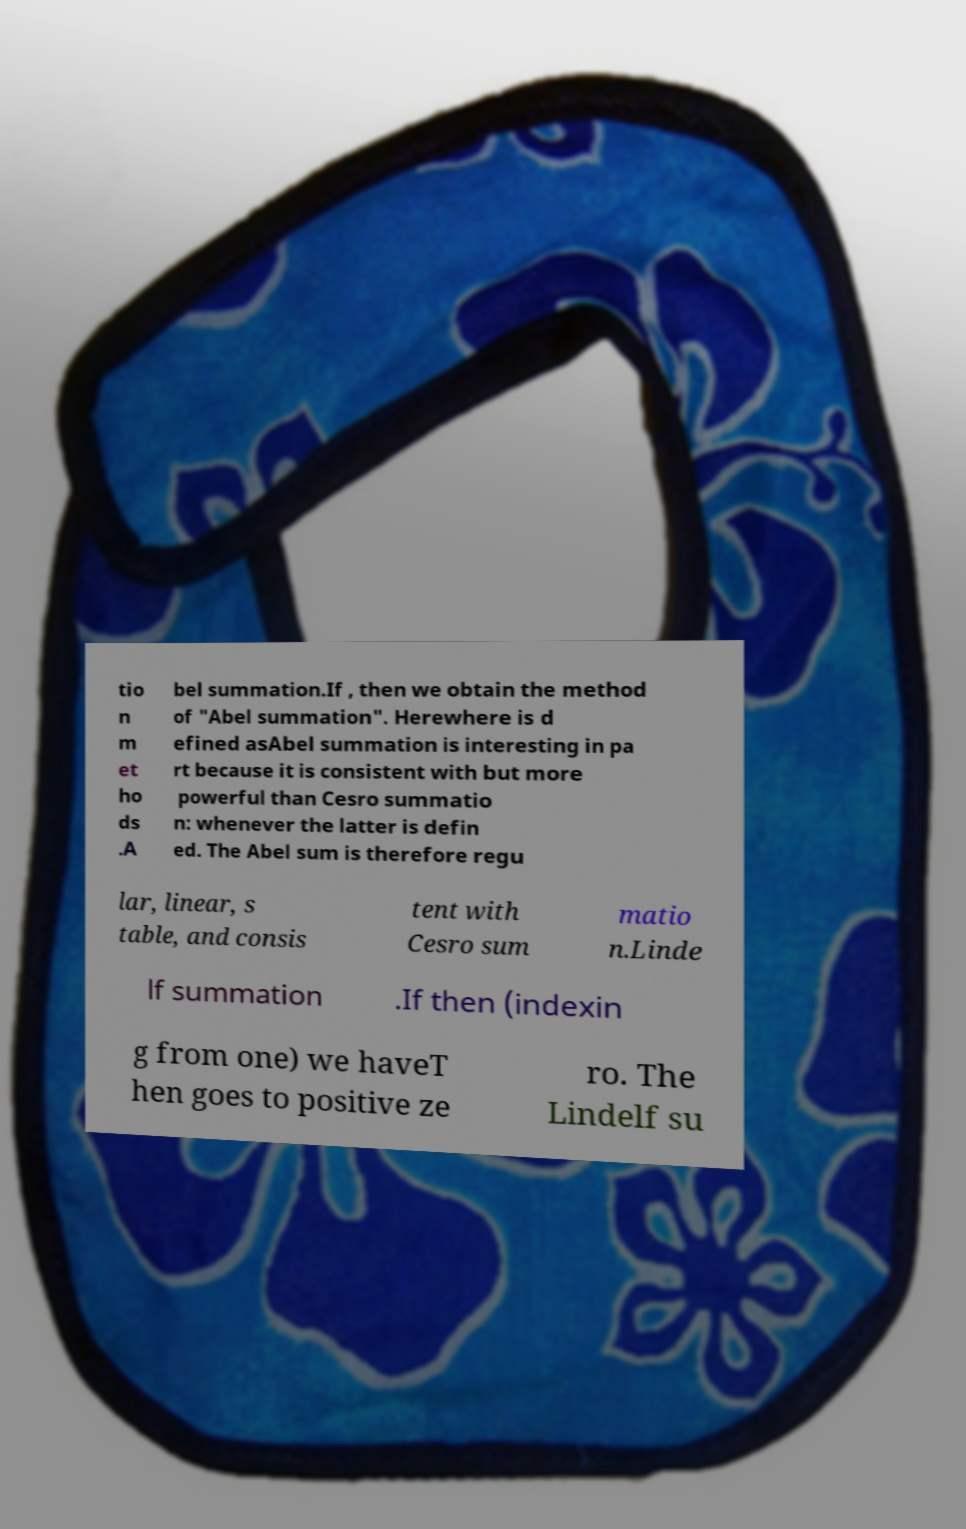What messages or text are displayed in this image? I need them in a readable, typed format. tio n m et ho ds .A bel summation.If , then we obtain the method of "Abel summation". Herewhere is d efined asAbel summation is interesting in pa rt because it is consistent with but more powerful than Cesro summatio n: whenever the latter is defin ed. The Abel sum is therefore regu lar, linear, s table, and consis tent with Cesro sum matio n.Linde lf summation .If then (indexin g from one) we haveT hen goes to positive ze ro. The Lindelf su 